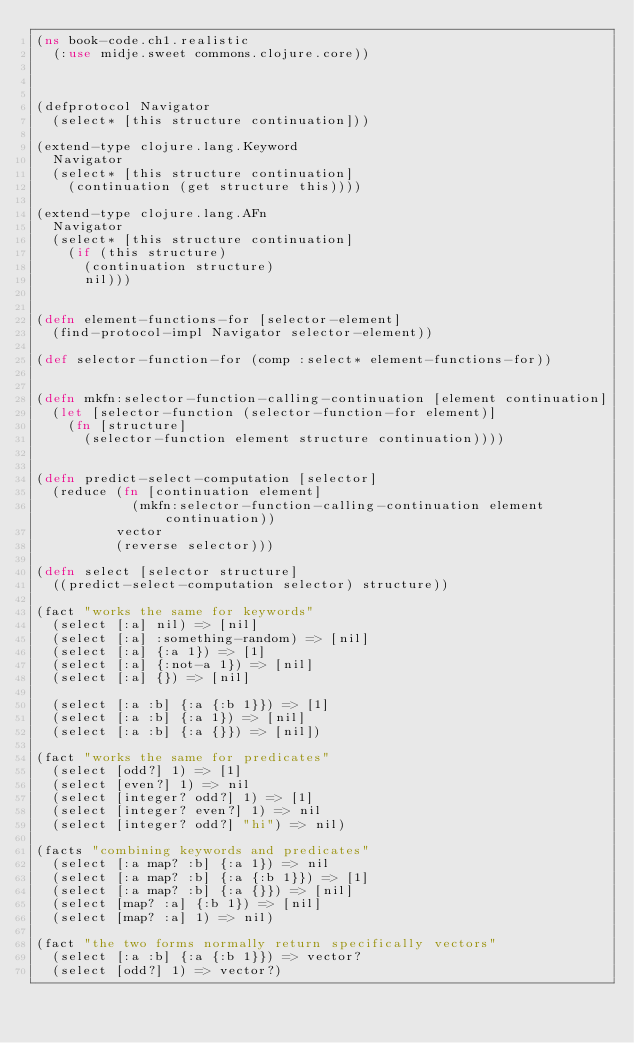<code> <loc_0><loc_0><loc_500><loc_500><_Clojure_>(ns book-code.ch1.realistic
  (:use midje.sweet commons.clojure.core))



(defprotocol Navigator
  (select* [this structure continuation]))

(extend-type clojure.lang.Keyword
  Navigator
  (select* [this structure continuation]
    (continuation (get structure this))))

(extend-type clojure.lang.AFn
  Navigator
  (select* [this structure continuation]
    (if (this structure)
      (continuation structure)
      nil)))


(defn element-functions-for [selector-element]
  (find-protocol-impl Navigator selector-element))

(def selector-function-for (comp :select* element-functions-for))


(defn mkfn:selector-function-calling-continuation [element continuation]
  (let [selector-function (selector-function-for element)]
    (fn [structure]
      (selector-function element structure continuation))))


(defn predict-select-computation [selector]
  (reduce (fn [continuation element]
            (mkfn:selector-function-calling-continuation element continuation))
          vector
          (reverse selector)))

(defn select [selector structure]
  ((predict-select-computation selector) structure))

(fact "works the same for keywords"
  (select [:a] nil) => [nil]
  (select [:a] :something-random) => [nil]
  (select [:a] {:a 1}) => [1]
  (select [:a] {:not-a 1}) => [nil]
  (select [:a] {}) => [nil]

  (select [:a :b] {:a {:b 1}}) => [1]
  (select [:a :b] {:a 1}) => [nil]
  (select [:a :b] {:a {}}) => [nil])

(fact "works the same for predicates"
  (select [odd?] 1) => [1]
  (select [even?] 1) => nil
  (select [integer? odd?] 1) => [1]
  (select [integer? even?] 1) => nil
  (select [integer? odd?] "hi") => nil)

(facts "combining keywords and predicates"
  (select [:a map? :b] {:a 1}) => nil
  (select [:a map? :b] {:a {:b 1}}) => [1]
  (select [:a map? :b] {:a {}}) => [nil]
  (select [map? :a] {:b 1}) => [nil]
  (select [map? :a] 1) => nil)

(fact "the two forms normally return specifically vectors"
  (select [:a :b] {:a {:b 1}}) => vector?
  (select [odd?] 1) => vector?)
</code> 